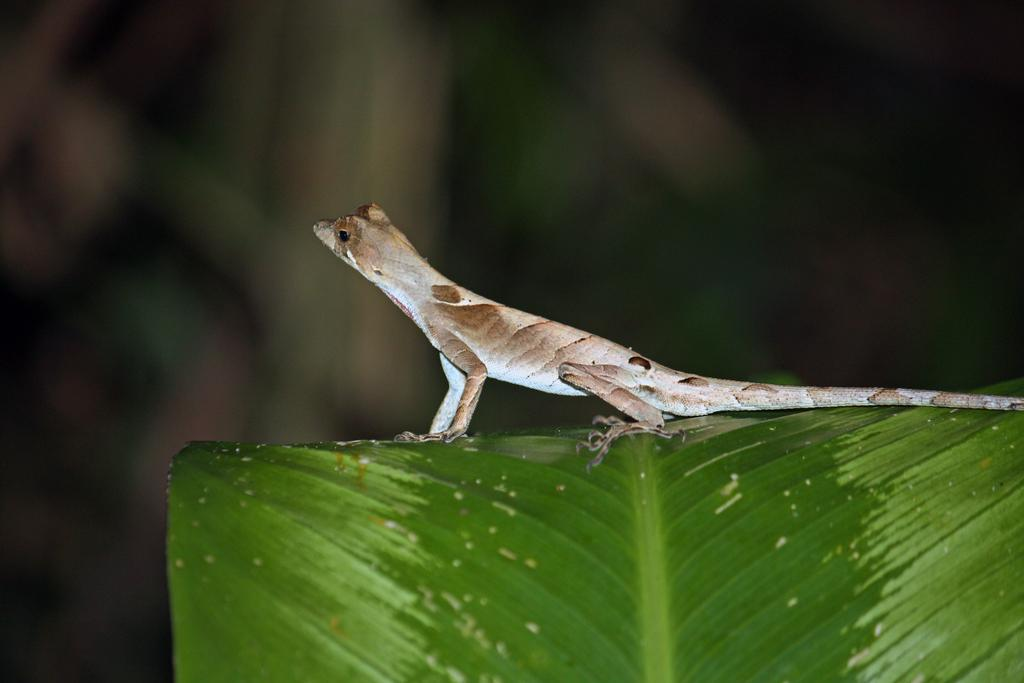What type of animal is in the image? There is a lizard in the image. How is the lizard positioned in the image? The lizard is truncated towards the right of the image. What other object is present in the image? There is a leaf in the image. How is the leaf positioned in the image? The leaf is truncated towards the bottom of the image. Can you describe the background of the image? The background of the image is blurred. What type of reward is the goat receiving in the image? There is no goat present in the image, and therefore no reward can be observed. How many eyes does the lizard have in the image? The number of eyes the lizard has cannot be determined from the image, as it is truncated towards the right. 